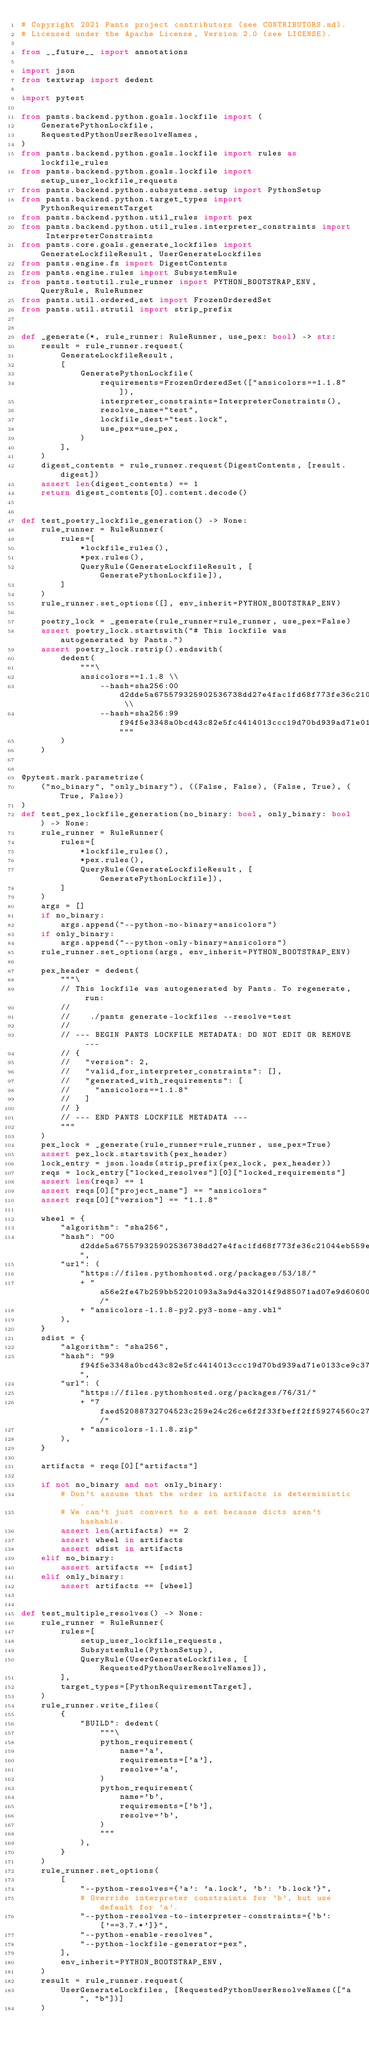Convert code to text. <code><loc_0><loc_0><loc_500><loc_500><_Python_># Copyright 2021 Pants project contributors (see CONTRIBUTORS.md).
# Licensed under the Apache License, Version 2.0 (see LICENSE).

from __future__ import annotations

import json
from textwrap import dedent

import pytest

from pants.backend.python.goals.lockfile import (
    GeneratePythonLockfile,
    RequestedPythonUserResolveNames,
)
from pants.backend.python.goals.lockfile import rules as lockfile_rules
from pants.backend.python.goals.lockfile import setup_user_lockfile_requests
from pants.backend.python.subsystems.setup import PythonSetup
from pants.backend.python.target_types import PythonRequirementTarget
from pants.backend.python.util_rules import pex
from pants.backend.python.util_rules.interpreter_constraints import InterpreterConstraints
from pants.core.goals.generate_lockfiles import GenerateLockfileResult, UserGenerateLockfiles
from pants.engine.fs import DigestContents
from pants.engine.rules import SubsystemRule
from pants.testutil.rule_runner import PYTHON_BOOTSTRAP_ENV, QueryRule, RuleRunner
from pants.util.ordered_set import FrozenOrderedSet
from pants.util.strutil import strip_prefix


def _generate(*, rule_runner: RuleRunner, use_pex: bool) -> str:
    result = rule_runner.request(
        GenerateLockfileResult,
        [
            GeneratePythonLockfile(
                requirements=FrozenOrderedSet(["ansicolors==1.1.8"]),
                interpreter_constraints=InterpreterConstraints(),
                resolve_name="test",
                lockfile_dest="test.lock",
                use_pex=use_pex,
            )
        ],
    )
    digest_contents = rule_runner.request(DigestContents, [result.digest])
    assert len(digest_contents) == 1
    return digest_contents[0].content.decode()


def test_poetry_lockfile_generation() -> None:
    rule_runner = RuleRunner(
        rules=[
            *lockfile_rules(),
            *pex.rules(),
            QueryRule(GenerateLockfileResult, [GeneratePythonLockfile]),
        ]
    )
    rule_runner.set_options([], env_inherit=PYTHON_BOOTSTRAP_ENV)

    poetry_lock = _generate(rule_runner=rule_runner, use_pex=False)
    assert poetry_lock.startswith("# This lockfile was autogenerated by Pants.")
    assert poetry_lock.rstrip().endswith(
        dedent(
            """\
            ansicolors==1.1.8 \\
                --hash=sha256:00d2dde5a675579325902536738dd27e4fac1fd68f773fe36c21044eb559e187 \\
                --hash=sha256:99f94f5e3348a0bcd43c82e5fc4414013ccc19d70bd939ad71e0133ce9c372e0"""
        )
    )


@pytest.mark.parametrize(
    ("no_binary", "only_binary"), ((False, False), (False, True), (True, False))
)
def test_pex_lockfile_generation(no_binary: bool, only_binary: bool) -> None:
    rule_runner = RuleRunner(
        rules=[
            *lockfile_rules(),
            *pex.rules(),
            QueryRule(GenerateLockfileResult, [GeneratePythonLockfile]),
        ]
    )
    args = []
    if no_binary:
        args.append("--python-no-binary=ansicolors")
    if only_binary:
        args.append("--python-only-binary=ansicolors")
    rule_runner.set_options(args, env_inherit=PYTHON_BOOTSTRAP_ENV)

    pex_header = dedent(
        """\
        // This lockfile was autogenerated by Pants. To regenerate, run:
        //
        //    ./pants generate-lockfiles --resolve=test
        //
        // --- BEGIN PANTS LOCKFILE METADATA: DO NOT EDIT OR REMOVE ---
        // {
        //   "version": 2,
        //   "valid_for_interpreter_constraints": [],
        //   "generated_with_requirements": [
        //     "ansicolors==1.1.8"
        //   ]
        // }
        // --- END PANTS LOCKFILE METADATA ---
        """
    )
    pex_lock = _generate(rule_runner=rule_runner, use_pex=True)
    assert pex_lock.startswith(pex_header)
    lock_entry = json.loads(strip_prefix(pex_lock, pex_header))
    reqs = lock_entry["locked_resolves"][0]["locked_requirements"]
    assert len(reqs) == 1
    assert reqs[0]["project_name"] == "ansicolors"
    assert reqs[0]["version"] == "1.1.8"

    wheel = {
        "algorithm": "sha256",
        "hash": "00d2dde5a675579325902536738dd27e4fac1fd68f773fe36c21044eb559e187",
        "url": (
            "https://files.pythonhosted.org/packages/53/18/"
            + "a56e2fe47b259bb52201093a3a9d4a32014f9d85071ad07e9d60600890ca/"
            + "ansicolors-1.1.8-py2.py3-none-any.whl"
        ),
    }
    sdist = {
        "algorithm": "sha256",
        "hash": "99f94f5e3348a0bcd43c82e5fc4414013ccc19d70bd939ad71e0133ce9c372e0",
        "url": (
            "https://files.pythonhosted.org/packages/76/31/"
            + "7faed52088732704523c259e24c26ce6f2f33fbeff2ff59274560c27628e/"
            + "ansicolors-1.1.8.zip"
        ),
    }

    artifacts = reqs[0]["artifacts"]

    if not no_binary and not only_binary:
        # Don't assume that the order in artifacts is deterministic.
        # We can't just convert to a set because dicts aren't hashable.
        assert len(artifacts) == 2
        assert wheel in artifacts
        assert sdist in artifacts
    elif no_binary:
        assert artifacts == [sdist]
    elif only_binary:
        assert artifacts == [wheel]


def test_multiple_resolves() -> None:
    rule_runner = RuleRunner(
        rules=[
            setup_user_lockfile_requests,
            SubsystemRule(PythonSetup),
            QueryRule(UserGenerateLockfiles, [RequestedPythonUserResolveNames]),
        ],
        target_types=[PythonRequirementTarget],
    )
    rule_runner.write_files(
        {
            "BUILD": dedent(
                """\
                python_requirement(
                    name='a',
                    requirements=['a'],
                    resolve='a',
                )
                python_requirement(
                    name='b',
                    requirements=['b'],
                    resolve='b',
                )
                """
            ),
        }
    )
    rule_runner.set_options(
        [
            "--python-resolves={'a': 'a.lock', 'b': 'b.lock'}",
            # Override interpreter constraints for 'b', but use default for 'a'.
            "--python-resolves-to-interpreter-constraints={'b': ['==3.7.*']}",
            "--python-enable-resolves",
            "--python-lockfile-generator=pex",
        ],
        env_inherit=PYTHON_BOOTSTRAP_ENV,
    )
    result = rule_runner.request(
        UserGenerateLockfiles, [RequestedPythonUserResolveNames(["a", "b"])]
    )</code> 